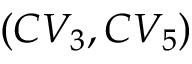Convert formula to latex. <formula><loc_0><loc_0><loc_500><loc_500>( C V _ { 3 } , C V _ { 5 } )</formula> 